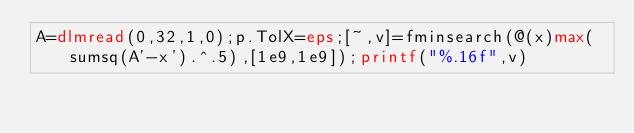Convert code to text. <code><loc_0><loc_0><loc_500><loc_500><_Octave_>A=dlmread(0,32,1,0);p.TolX=eps;[~,v]=fminsearch(@(x)max(sumsq(A'-x').^.5),[1e9,1e9]);printf("%.16f",v)</code> 